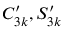<formula> <loc_0><loc_0><loc_500><loc_500>C _ { 3 k } ^ { \prime } , S _ { 3 k } ^ { \prime }</formula> 